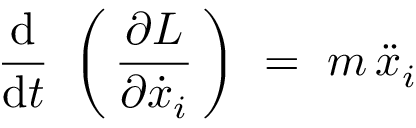Convert formula to latex. <formula><loc_0><loc_0><loc_500><loc_500>{ \frac { d } { d t } } \ \left ( \, { \frac { \partial L } { \partial { \dot { x } } _ { i } } } \, \right ) \ = \ m \, { \ddot { x } } _ { i }</formula> 